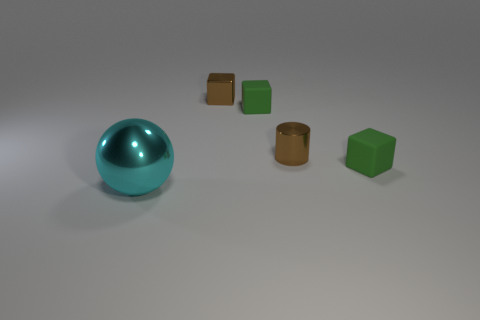Are there any large blue matte things of the same shape as the cyan metal object?
Your response must be concise. No. What material is the object that is the same color as the tiny cylinder?
Your response must be concise. Metal. What shape is the big cyan object to the left of the tiny brown metallic cylinder?
Your response must be concise. Sphere. How many large brown rubber balls are there?
Ensure brevity in your answer.  0. The tiny thing that is the same material as the cylinder is what color?
Provide a succinct answer. Brown. How many tiny things are either cyan spheres or rubber cylinders?
Keep it short and to the point. 0. There is a brown metal cylinder; what number of cyan things are behind it?
Your answer should be very brief. 0. What number of matte things are either large cyan things or green things?
Ensure brevity in your answer.  2. Is there a block right of the green cube that is behind the tiny matte cube in front of the metallic cylinder?
Provide a short and direct response. Yes. What color is the small metal cylinder?
Ensure brevity in your answer.  Brown. 